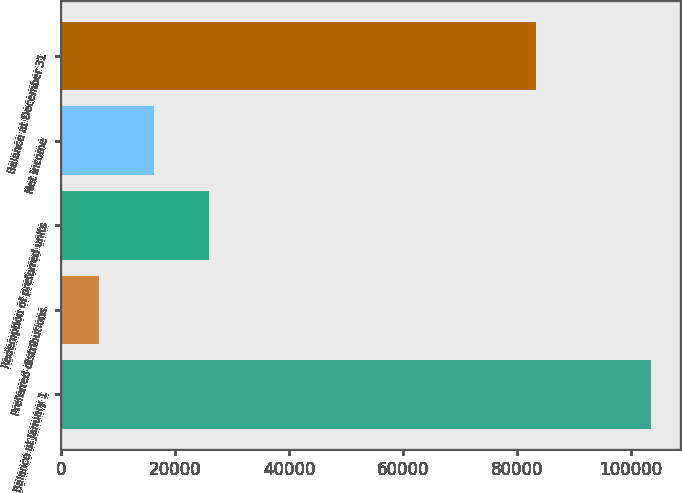<chart> <loc_0><loc_0><loc_500><loc_500><bar_chart><fcel>Balance at January 1<fcel>Preferred distributions<fcel>Redemption of preferred units<fcel>Net income<fcel>Balance at December 31<nl><fcel>103428<fcel>6683<fcel>26032<fcel>16357.5<fcel>83384<nl></chart> 